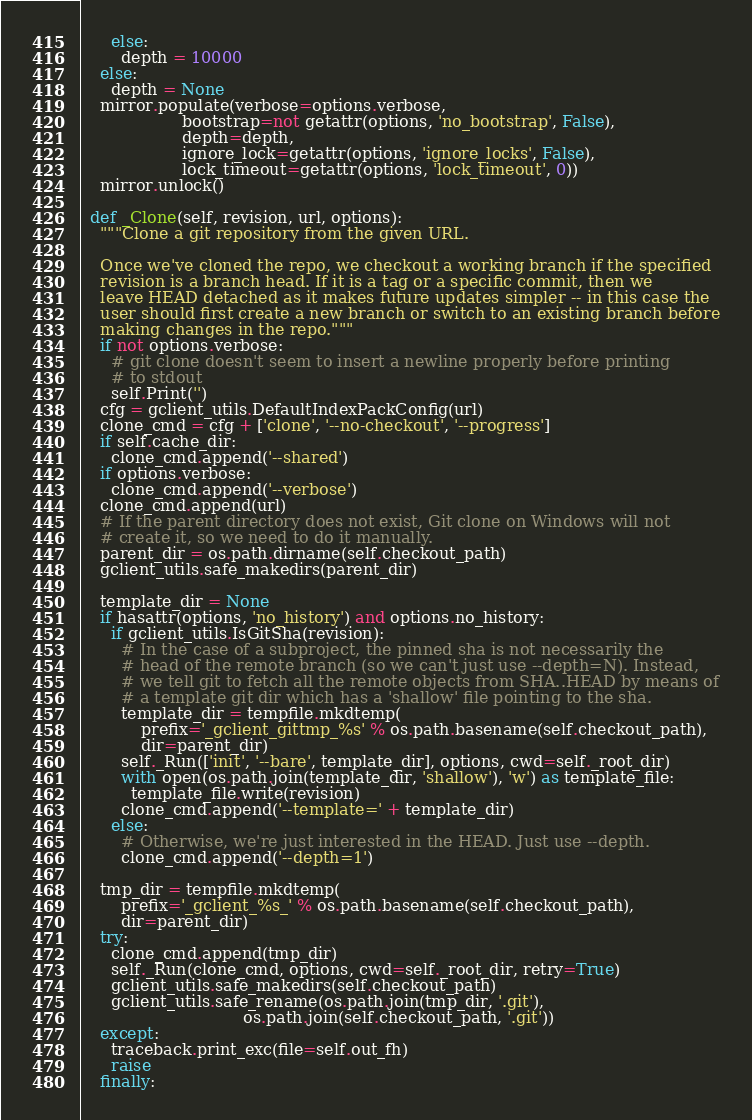Convert code to text. <code><loc_0><loc_0><loc_500><loc_500><_Python_>      else:
        depth = 10000
    else:
      depth = None
    mirror.populate(verbose=options.verbose,
                    bootstrap=not getattr(options, 'no_bootstrap', False),
                    depth=depth,
                    ignore_lock=getattr(options, 'ignore_locks', False),
                    lock_timeout=getattr(options, 'lock_timeout', 0))
    mirror.unlock()

  def _Clone(self, revision, url, options):
    """Clone a git repository from the given URL.

    Once we've cloned the repo, we checkout a working branch if the specified
    revision is a branch head. If it is a tag or a specific commit, then we
    leave HEAD detached as it makes future updates simpler -- in this case the
    user should first create a new branch or switch to an existing branch before
    making changes in the repo."""
    if not options.verbose:
      # git clone doesn't seem to insert a newline properly before printing
      # to stdout
      self.Print('')
    cfg = gclient_utils.DefaultIndexPackConfig(url)
    clone_cmd = cfg + ['clone', '--no-checkout', '--progress']
    if self.cache_dir:
      clone_cmd.append('--shared')
    if options.verbose:
      clone_cmd.append('--verbose')
    clone_cmd.append(url)
    # If the parent directory does not exist, Git clone on Windows will not
    # create it, so we need to do it manually.
    parent_dir = os.path.dirname(self.checkout_path)
    gclient_utils.safe_makedirs(parent_dir)

    template_dir = None
    if hasattr(options, 'no_history') and options.no_history:
      if gclient_utils.IsGitSha(revision):
        # In the case of a subproject, the pinned sha is not necessarily the
        # head of the remote branch (so we can't just use --depth=N). Instead,
        # we tell git to fetch all the remote objects from SHA..HEAD by means of
        # a template git dir which has a 'shallow' file pointing to the sha.
        template_dir = tempfile.mkdtemp(
            prefix='_gclient_gittmp_%s' % os.path.basename(self.checkout_path),
            dir=parent_dir)
        self._Run(['init', '--bare', template_dir], options, cwd=self._root_dir)
        with open(os.path.join(template_dir, 'shallow'), 'w') as template_file:
          template_file.write(revision)
        clone_cmd.append('--template=' + template_dir)
      else:
        # Otherwise, we're just interested in the HEAD. Just use --depth.
        clone_cmd.append('--depth=1')

    tmp_dir = tempfile.mkdtemp(
        prefix='_gclient_%s_' % os.path.basename(self.checkout_path),
        dir=parent_dir)
    try:
      clone_cmd.append(tmp_dir)
      self._Run(clone_cmd, options, cwd=self._root_dir, retry=True)
      gclient_utils.safe_makedirs(self.checkout_path)
      gclient_utils.safe_rename(os.path.join(tmp_dir, '.git'),
                                os.path.join(self.checkout_path, '.git'))
    except:
      traceback.print_exc(file=self.out_fh)
      raise
    finally:</code> 